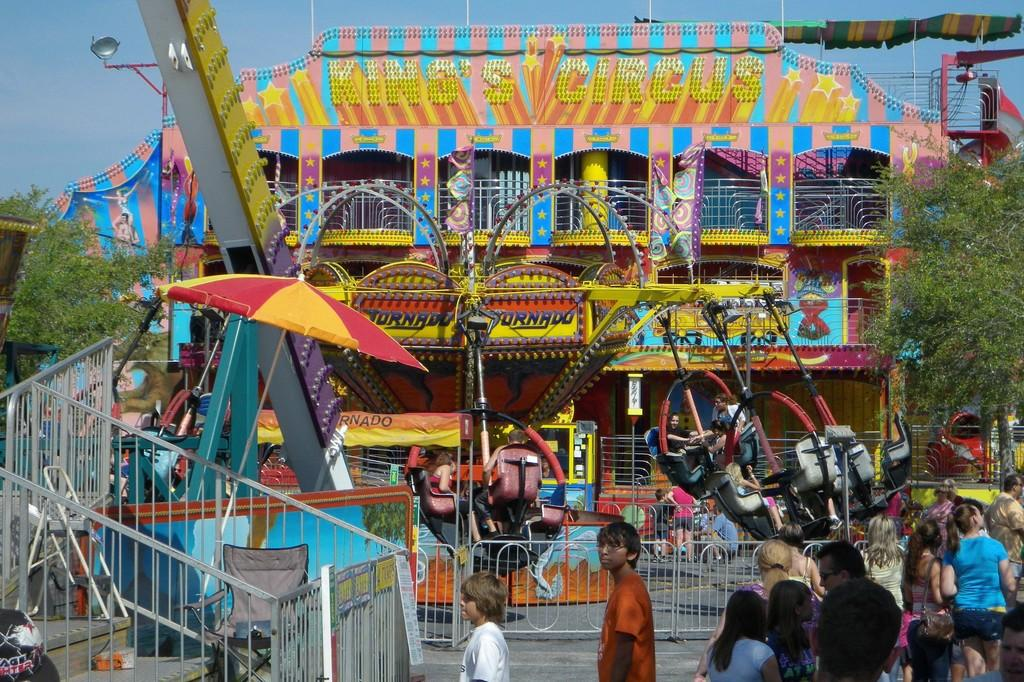What type of event is taking place in the image? The image depicts a circus. What can be seen near the people on the right side of the image? There are railings in the image. What type of natural elements are present in the image? There are trees in the image. What is visible in the background of the image? The sky is visible in the background of the image. What type of cart is being used to transport the button on the wrist in the image? There is no cart, button, or wrist present in the image; it depicts a circus scene. 